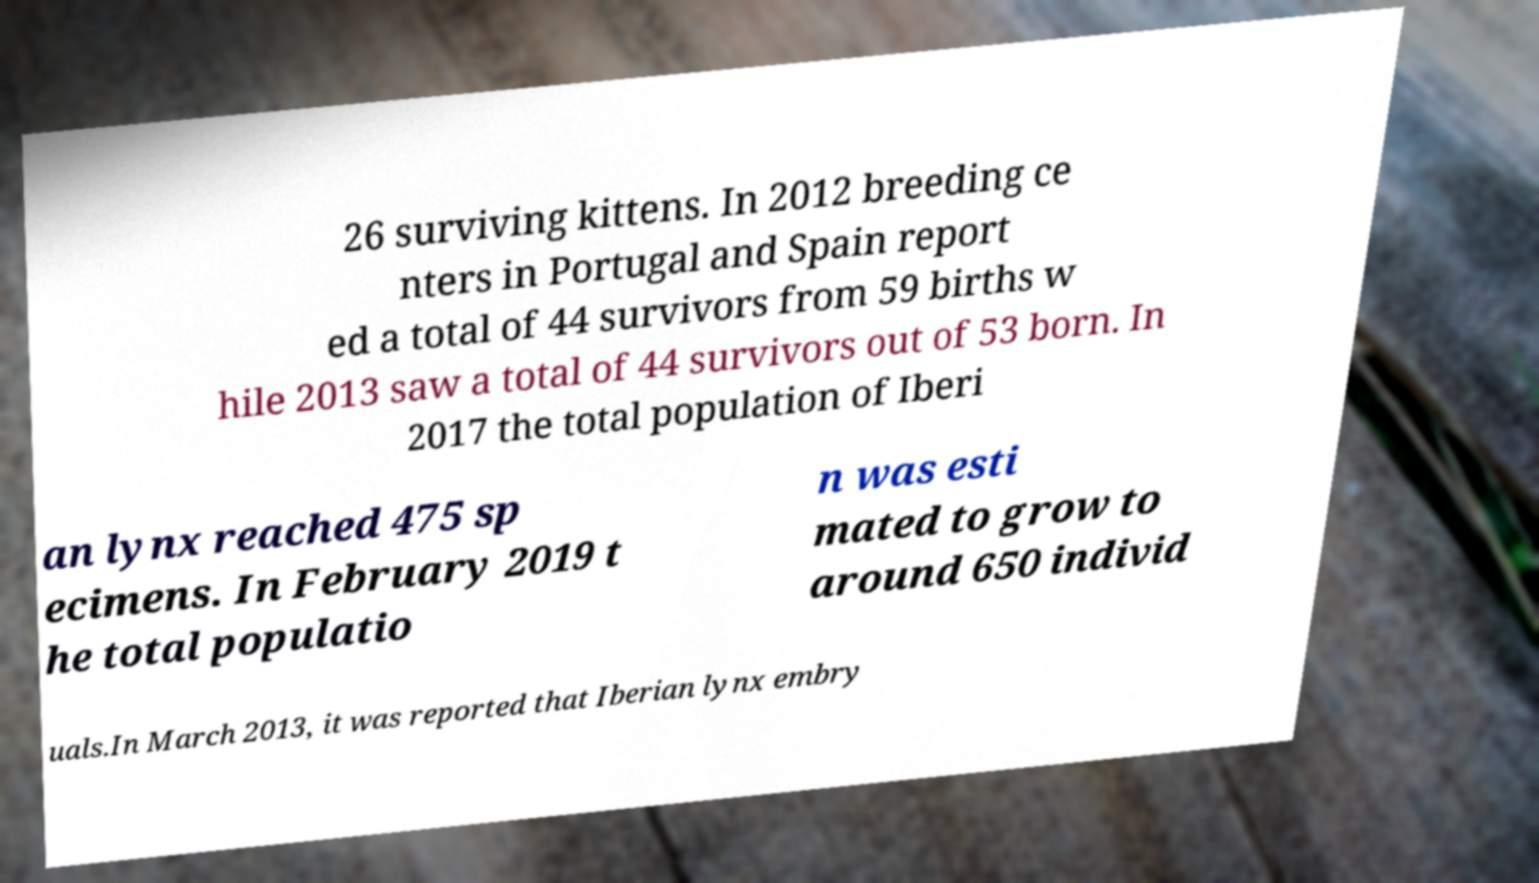There's text embedded in this image that I need extracted. Can you transcribe it verbatim? 26 surviving kittens. In 2012 breeding ce nters in Portugal and Spain report ed a total of 44 survivors from 59 births w hile 2013 saw a total of 44 survivors out of 53 born. In 2017 the total population of Iberi an lynx reached 475 sp ecimens. In February 2019 t he total populatio n was esti mated to grow to around 650 individ uals.In March 2013, it was reported that Iberian lynx embry 